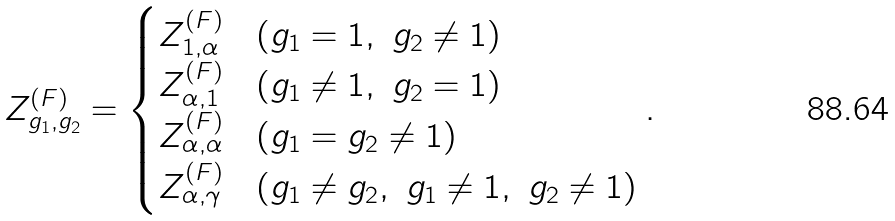Convert formula to latex. <formula><loc_0><loc_0><loc_500><loc_500>Z ^ { ( F ) } _ { g _ { 1 } , g _ { 2 } } = \begin{cases} Z ^ { ( F ) } _ { 1 , \alpha } & ( g _ { 1 } = 1 , \ g _ { 2 } \ne 1 ) \\ Z ^ { ( F ) } _ { \alpha , 1 } & ( g _ { 1 } \ne 1 , \ g _ { 2 } = 1 ) \\ Z ^ { ( F ) } _ { \alpha , \alpha } & ( g _ { 1 } = g _ { 2 } \ne 1 ) \\ Z ^ { ( F ) } _ { \alpha , \gamma } & ( g _ { 1 } \ne g _ { 2 } , \ g _ { 1 } \ne 1 , \ g _ { 2 } \ne 1 ) \\ \end{cases} .</formula> 